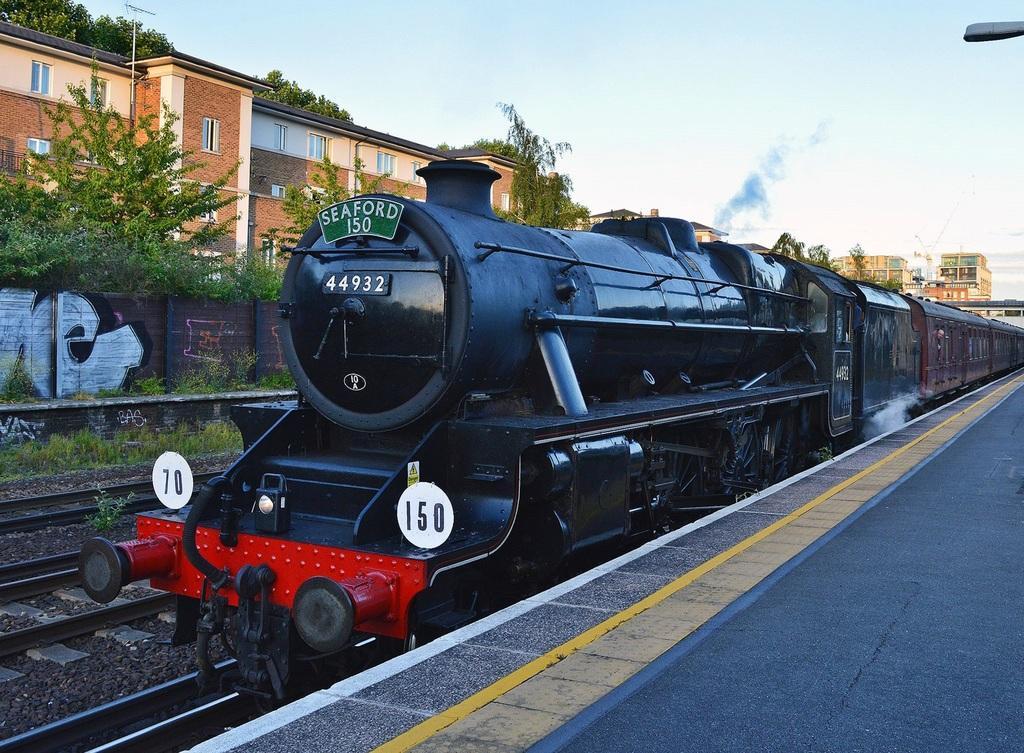Describe this image in one or two sentences. In this picture there is a train in the center of the image and there are buildings and trees in the background area of the image and there is a platform in the bottom right side of the image. 